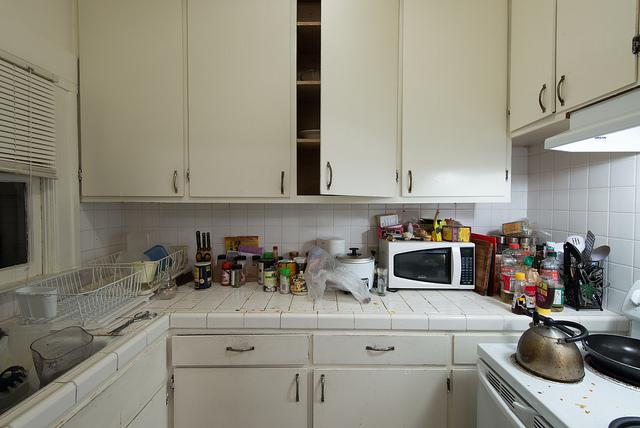What room is this?
Concise answer only. Kitchen. Is this kitchen clean?
Answer briefly. No. What is the largest object in the sink?
Give a very brief answer. Pitcher. 